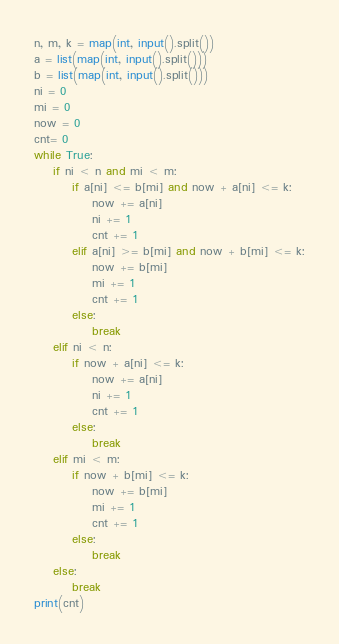Convert code to text. <code><loc_0><loc_0><loc_500><loc_500><_Python_>n, m, k = map(int, input().split())
a = list(map(int, input().split()))
b = list(map(int, input().split()))
ni = 0
mi = 0
now = 0
cnt= 0
while True:
    if ni < n and mi < m:
        if a[ni] <= b[mi] and now + a[ni] <= k:
            now += a[ni]
            ni += 1
            cnt += 1
        elif a[ni] >= b[mi] and now + b[mi] <= k:
            now += b[mi]
            mi += 1
            cnt += 1
        else:
            break
    elif ni < n:
        if now + a[ni] <= k:
            now += a[ni]
            ni += 1
            cnt += 1
        else:
            break
    elif mi < m:
        if now + b[mi] <= k:
            now += b[mi]
            mi += 1
            cnt += 1
        else:
            break
    else:
        break
print(cnt)</code> 